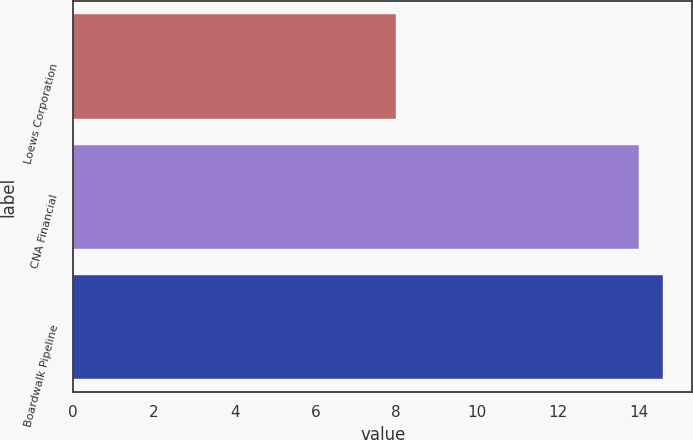Convert chart to OTSL. <chart><loc_0><loc_0><loc_500><loc_500><bar_chart><fcel>Loews Corporation<fcel>CNA Financial<fcel>Boardwalk Pipeline<nl><fcel>8<fcel>14<fcel>14.6<nl></chart> 